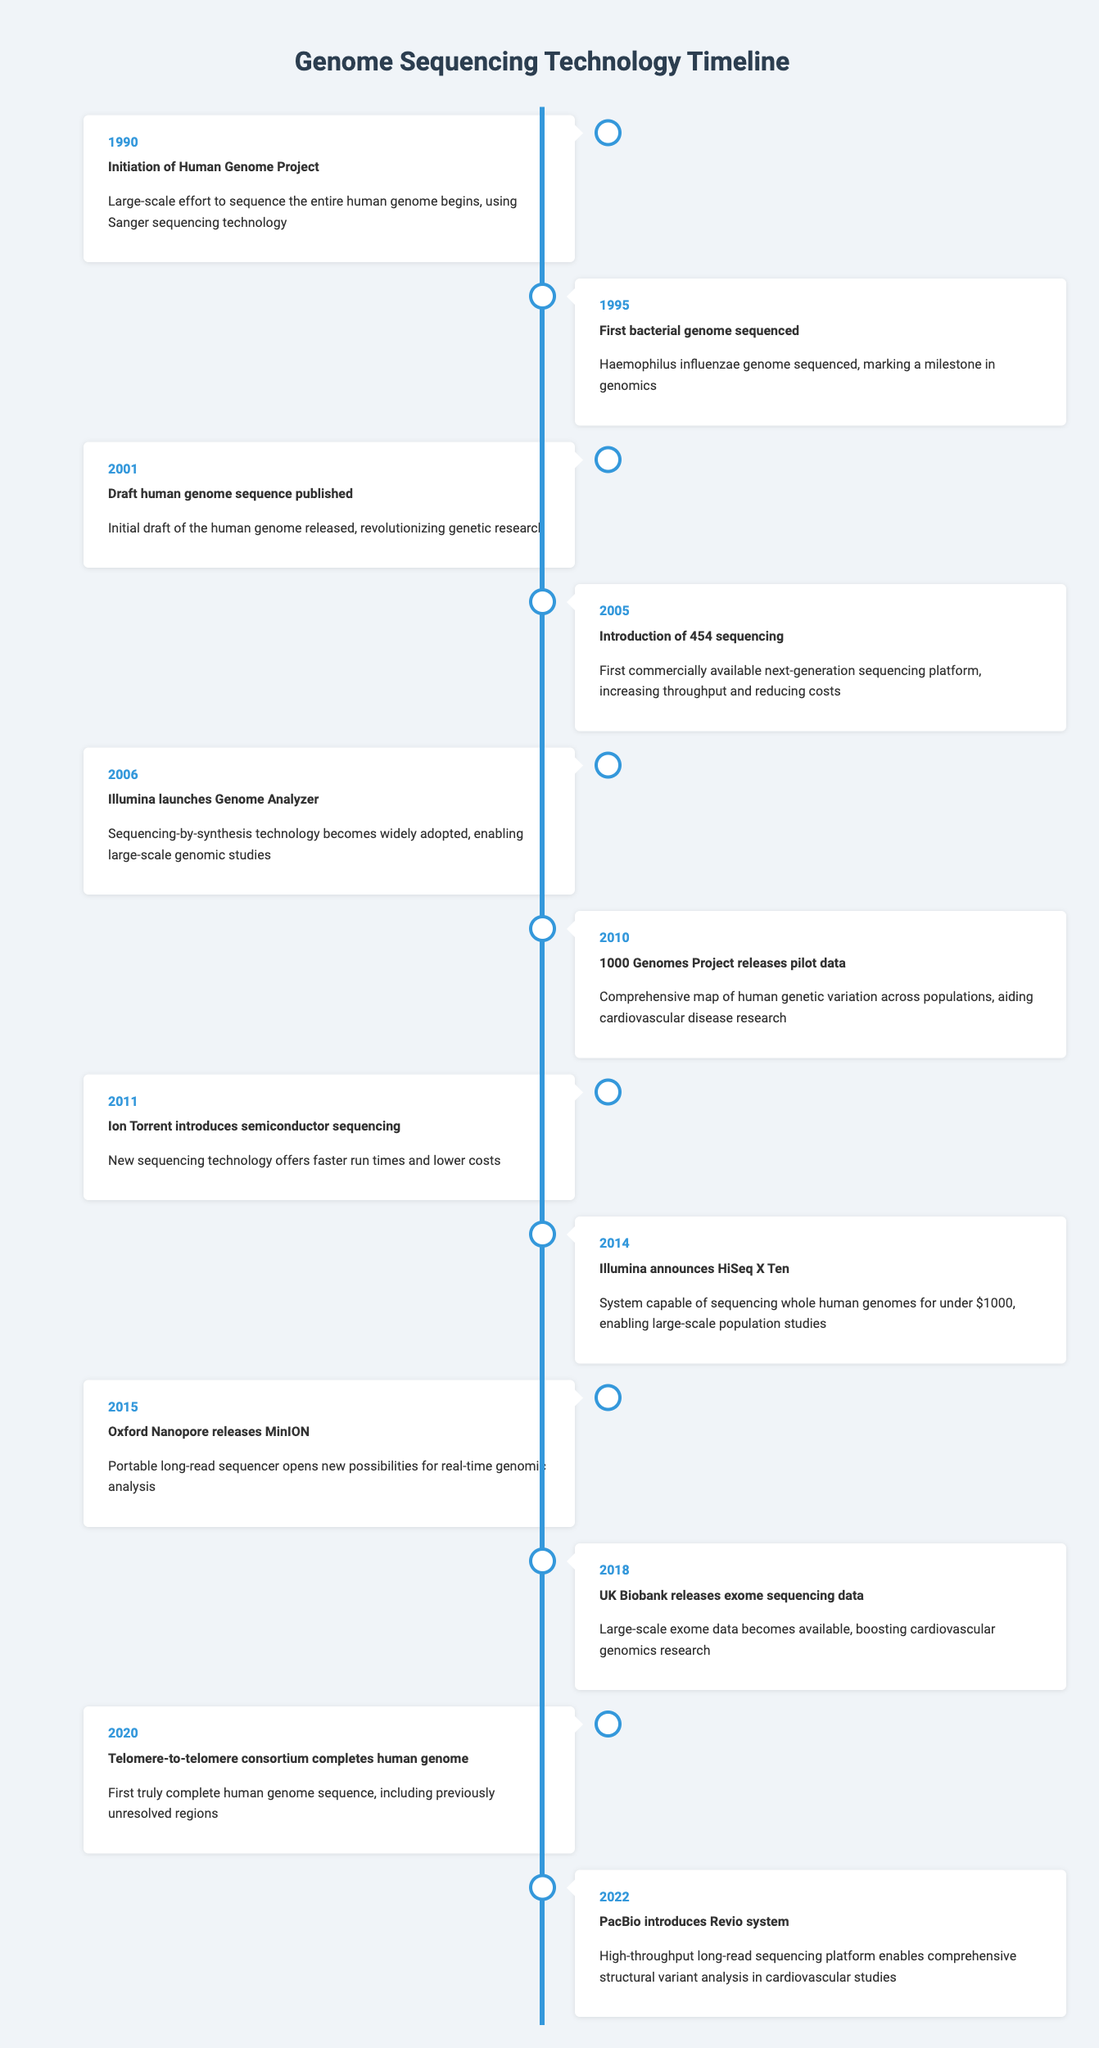What year did the Human Genome Project begin? The Human Genome Project was initiated in 1990 according to the timeline.
Answer: 1990 Which sequencing technology was first introduced commercially in 2005? In 2005, 454 sequencing was introduced as the first commercially available next-generation sequencing platform.
Answer: 454 sequencing How many years apart were the first bacterial genome sequencing and the draft human genome sequence publication? The first bacterial genome was sequenced in 1995, and the draft human genome was published in 2001. The difference is 2001 - 1995 = 6 years.
Answer: 6 years Did the UK Biobank release exome sequencing data before 2018? No, the UK Biobank released exome sequencing data in 2018, making it impossible for this release to have occurred prior to that year.
Answer: No Which event marked the completion of the first truly complete human genome sequence? The completion of the first truly complete human genome sequence was achieved by the Telomere-to-telomere consortium in 2020.
Answer: Telomere-to-telomere consortium completes human genome What significant advancement did PacBio achieve in 2022? In 2022, PacBio introduced the Revio system, which is a high-throughput long-read sequencing platform that enables comprehensive structural variant analysis in cardiovascular studies.
Answer: High-throughput long-read sequencing platform Count the total number of events listed in the timeline. There are 12 distinct events listed in the timeline based on the provided data from 1990 to 2022.
Answer: 12 events Compare the sequencing technologies introduced in 2005 and 2011 in terms of their capabilities. In 2005, 454 sequencing technology was introduced, which increased throughput and reduced costs. In 2011, Ion Torrent introduced semiconductor sequencing, offering faster run times and lower costs. Both technologies enhanced sequencing capabilities, but they were distinct in their approaches.
Answer: Both enhance capabilities; 454 improved throughput, Ion Torrent offered speed Which sequencing event had a significant impact on cardiovascular disease research? The 1000 Genomes Project releasing pilot data in 2010 had a comprehensive impact on mapping human genetic variation, particularly aiding in cardiovascular disease research.
Answer: 1000 Genomes Project releases pilot data 